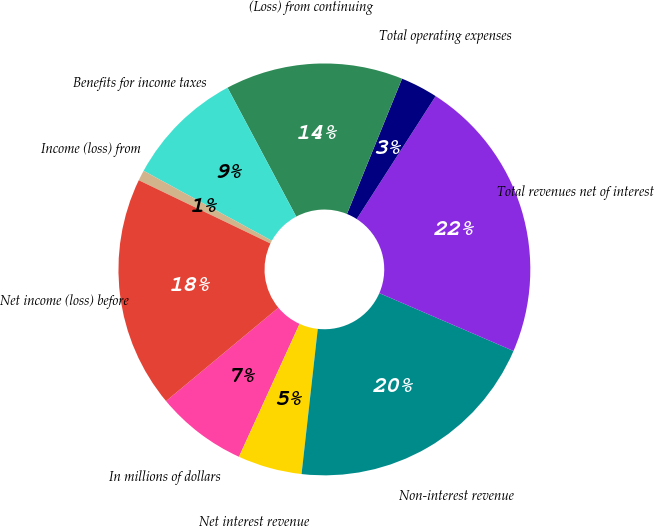Convert chart. <chart><loc_0><loc_0><loc_500><loc_500><pie_chart><fcel>In millions of dollars<fcel>Net interest revenue<fcel>Non-interest revenue<fcel>Total revenues net of interest<fcel>Total operating expenses<fcel>(Loss) from continuing<fcel>Benefits for income taxes<fcel>Income (loss) from<fcel>Net income (loss) before<nl><fcel>7.15%<fcel>5.04%<fcel>20.29%<fcel>22.4%<fcel>2.93%<fcel>13.95%<fcel>9.26%<fcel>0.82%<fcel>18.17%<nl></chart> 